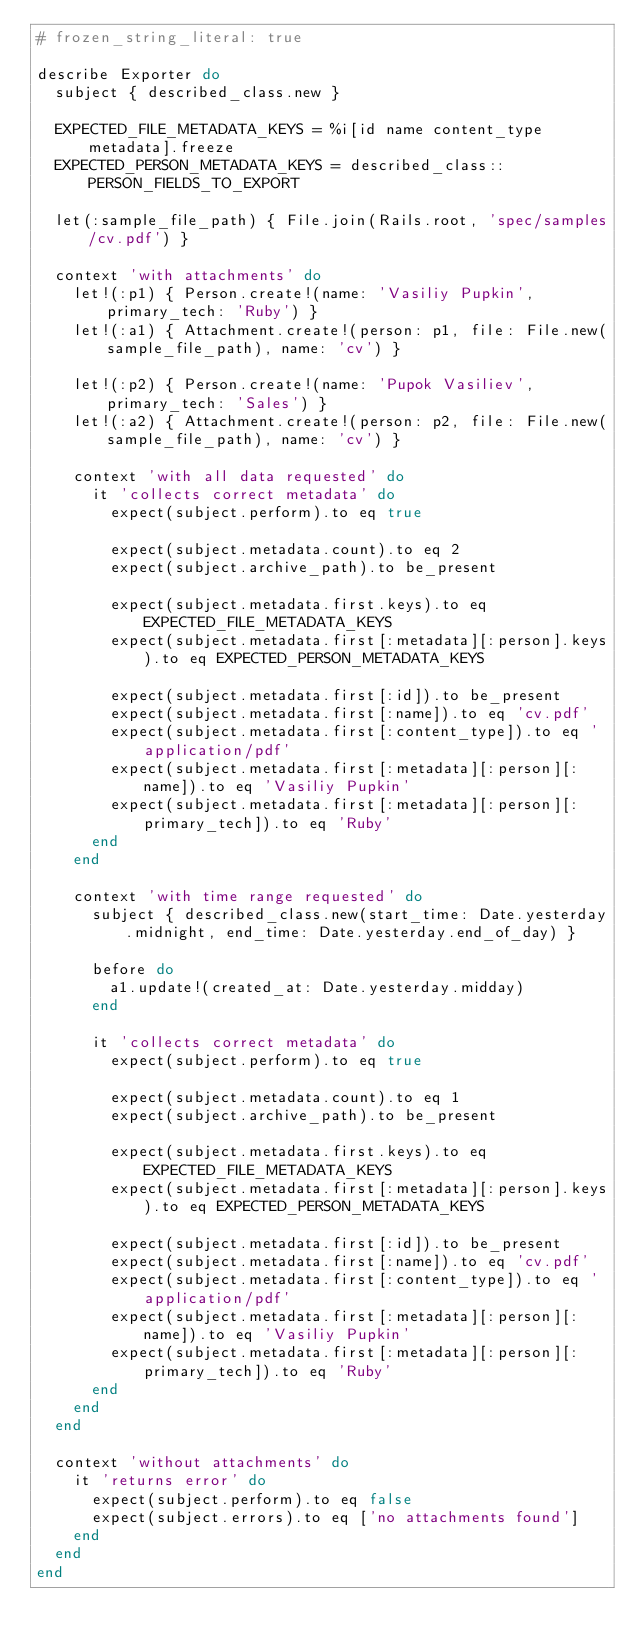<code> <loc_0><loc_0><loc_500><loc_500><_Ruby_># frozen_string_literal: true

describe Exporter do
  subject { described_class.new }

  EXPECTED_FILE_METADATA_KEYS = %i[id name content_type metadata].freeze
  EXPECTED_PERSON_METADATA_KEYS = described_class::PERSON_FIELDS_TO_EXPORT

  let(:sample_file_path) { File.join(Rails.root, 'spec/samples/cv.pdf') }

  context 'with attachments' do
    let!(:p1) { Person.create!(name: 'Vasiliy Pupkin', primary_tech: 'Ruby') }
    let!(:a1) { Attachment.create!(person: p1, file: File.new(sample_file_path), name: 'cv') }

    let!(:p2) { Person.create!(name: 'Pupok Vasiliev', primary_tech: 'Sales') }
    let!(:a2) { Attachment.create!(person: p2, file: File.new(sample_file_path), name: 'cv') }

    context 'with all data requested' do
      it 'collects correct metadata' do
        expect(subject.perform).to eq true

        expect(subject.metadata.count).to eq 2
        expect(subject.archive_path).to be_present

        expect(subject.metadata.first.keys).to eq EXPECTED_FILE_METADATA_KEYS
        expect(subject.metadata.first[:metadata][:person].keys).to eq EXPECTED_PERSON_METADATA_KEYS

        expect(subject.metadata.first[:id]).to be_present
        expect(subject.metadata.first[:name]).to eq 'cv.pdf'
        expect(subject.metadata.first[:content_type]).to eq 'application/pdf'
        expect(subject.metadata.first[:metadata][:person][:name]).to eq 'Vasiliy Pupkin'
        expect(subject.metadata.first[:metadata][:person][:primary_tech]).to eq 'Ruby'
      end
    end

    context 'with time range requested' do
      subject { described_class.new(start_time: Date.yesterday.midnight, end_time: Date.yesterday.end_of_day) }

      before do
        a1.update!(created_at: Date.yesterday.midday)
      end

      it 'collects correct metadata' do
        expect(subject.perform).to eq true

        expect(subject.metadata.count).to eq 1
        expect(subject.archive_path).to be_present

        expect(subject.metadata.first.keys).to eq EXPECTED_FILE_METADATA_KEYS
        expect(subject.metadata.first[:metadata][:person].keys).to eq EXPECTED_PERSON_METADATA_KEYS

        expect(subject.metadata.first[:id]).to be_present
        expect(subject.metadata.first[:name]).to eq 'cv.pdf'
        expect(subject.metadata.first[:content_type]).to eq 'application/pdf'
        expect(subject.metadata.first[:metadata][:person][:name]).to eq 'Vasiliy Pupkin'
        expect(subject.metadata.first[:metadata][:person][:primary_tech]).to eq 'Ruby'
      end
    end
  end

  context 'without attachments' do
    it 'returns error' do
      expect(subject.perform).to eq false
      expect(subject.errors).to eq ['no attachments found']
    end
  end
end
</code> 